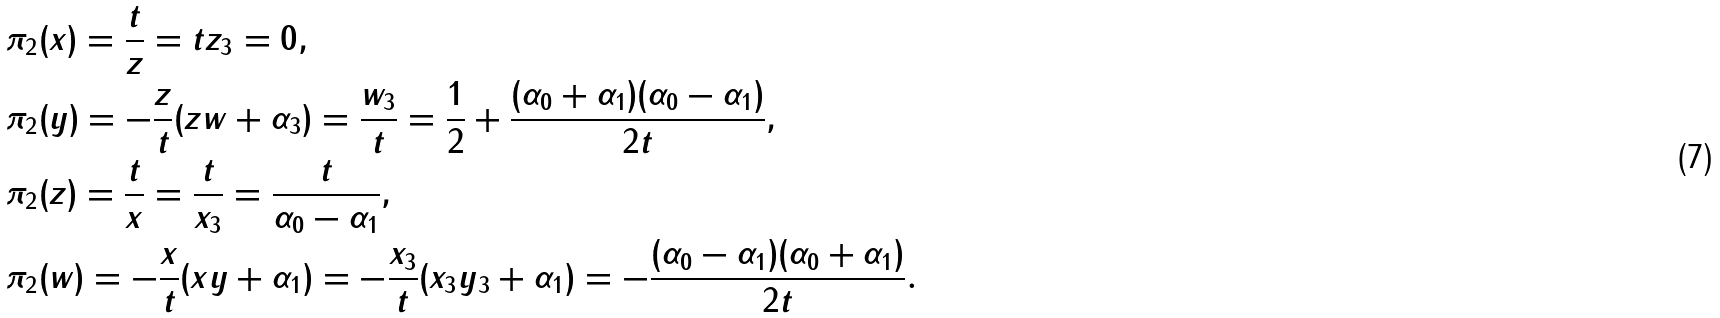<formula> <loc_0><loc_0><loc_500><loc_500>& \pi _ { 2 } ( x ) = \frac { t } { z } = t z _ { 3 } = 0 , \\ & \pi _ { 2 } ( y ) = - \frac { z } { t } ( z w + \alpha _ { 3 } ) = \frac { w _ { 3 } } { t } = \frac { 1 } { 2 } + \frac { ( \alpha _ { 0 } + \alpha _ { 1 } ) ( \alpha _ { 0 } - \alpha _ { 1 } ) } { 2 t } , \\ & \pi _ { 2 } ( z ) = \frac { t } { x } = \frac { t } { x _ { 3 } } = \frac { t } { \alpha _ { 0 } - \alpha _ { 1 } } , \\ & \pi _ { 2 } ( w ) = - \frac { x } { t } ( x y + \alpha _ { 1 } ) = - \frac { x _ { 3 } } { t } ( x _ { 3 } y _ { 3 } + \alpha _ { 1 } ) = - \frac { ( \alpha _ { 0 } - \alpha _ { 1 } ) ( \alpha _ { 0 } + \alpha _ { 1 } ) } { 2 t } .</formula> 